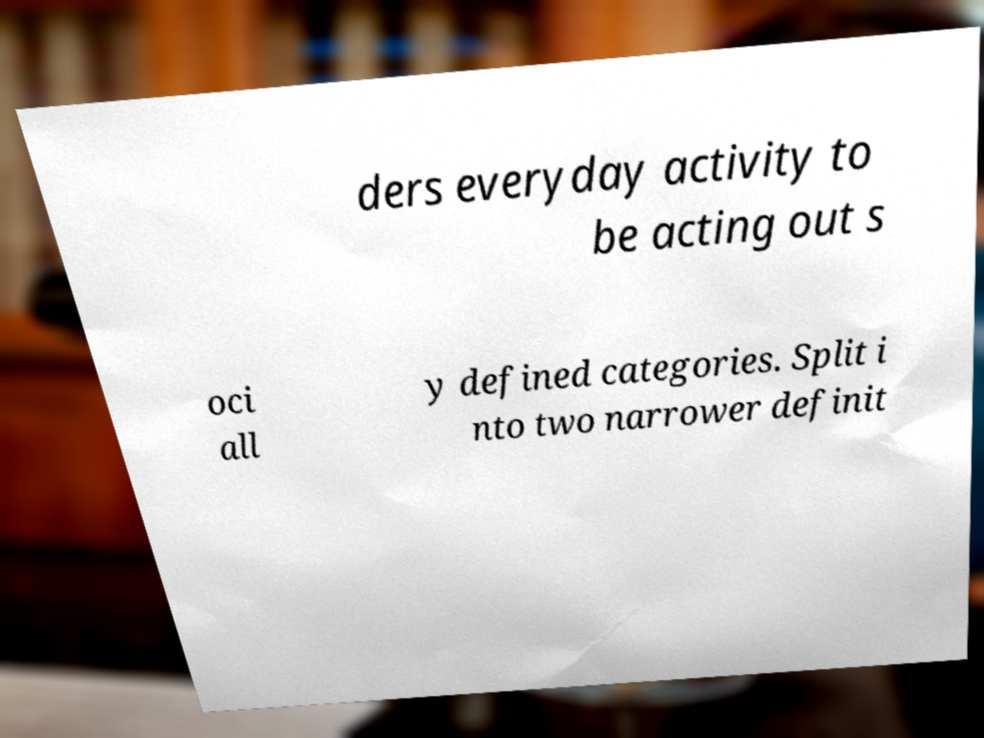Please identify and transcribe the text found in this image. ders everyday activity to be acting out s oci all y defined categories. Split i nto two narrower definit 